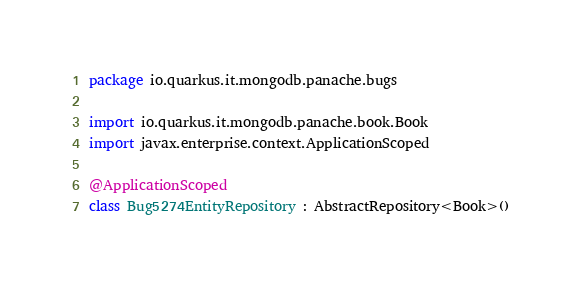<code> <loc_0><loc_0><loc_500><loc_500><_Kotlin_>package io.quarkus.it.mongodb.panache.bugs

import io.quarkus.it.mongodb.panache.book.Book
import javax.enterprise.context.ApplicationScoped

@ApplicationScoped
class Bug5274EntityRepository : AbstractRepository<Book>()</code> 